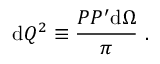Convert formula to latex. <formula><loc_0><loc_0><loc_500><loc_500>d Q ^ { 2 } \equiv \frac { P P ^ { \prime } d \Omega } { \pi } .</formula> 